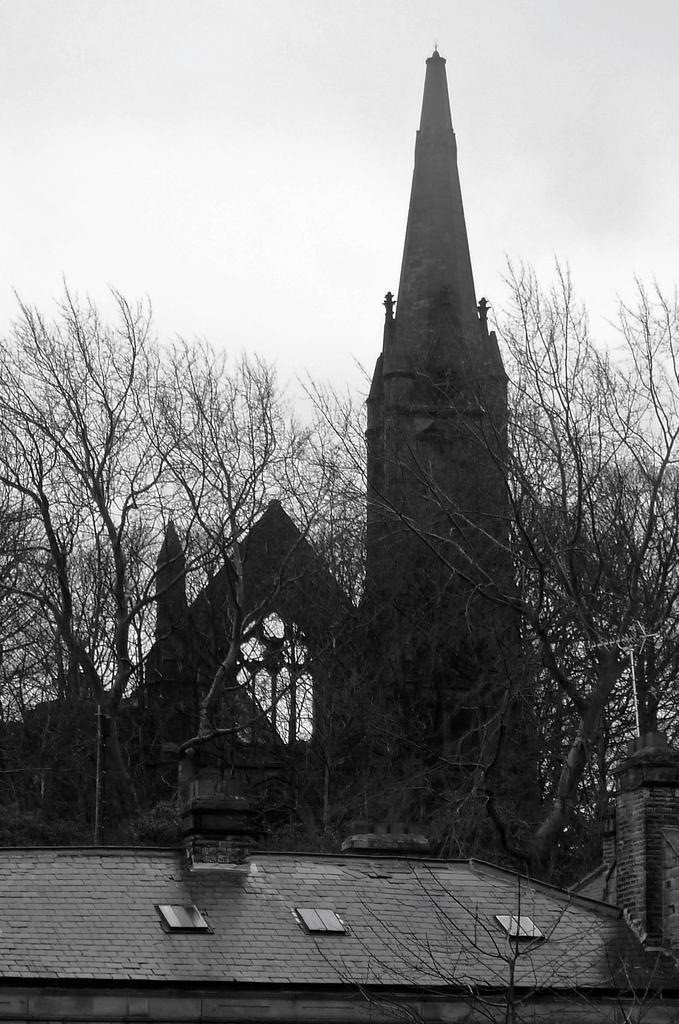In one or two sentences, can you explain what this image depicts? Here in this picture we can see an old building present over a place and we can also see plants and trees covered over there and we can see the sky is cloudy. 